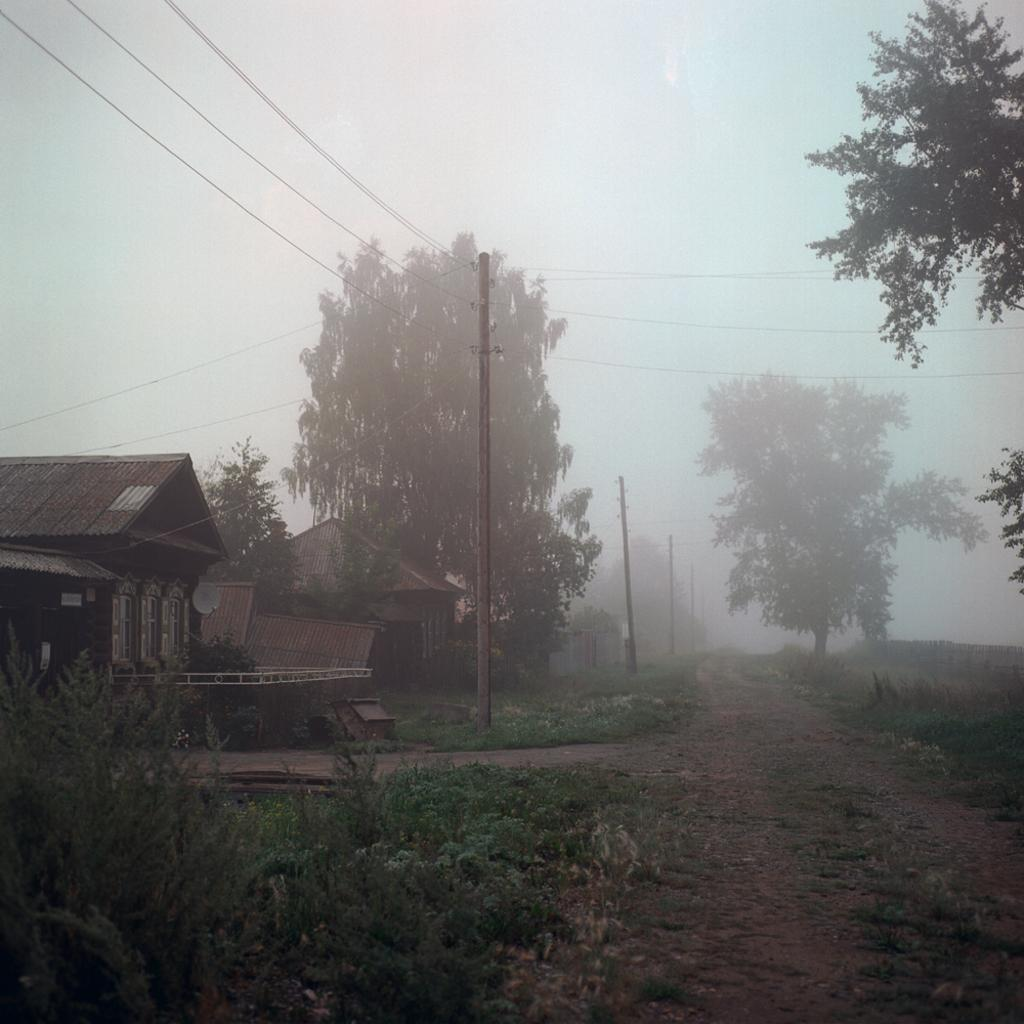What is the main feature of the image? There is a path in the image. What can be seen on either side of the path? Plants and trees are present on either side of the path. What other objects are present on either side of the path? Poles are present on either side of the path. What can be seen in the background of the image? There are houses and the sky visible in the background of the image. What type of juice is being squeezed from the seed in the image? There is no juice or seed present in the image. What sense is being stimulated by the image? The image does not stimulate any specific sense; it is a visual representation of a path with plants, trees, poles, houses, and the sky. 